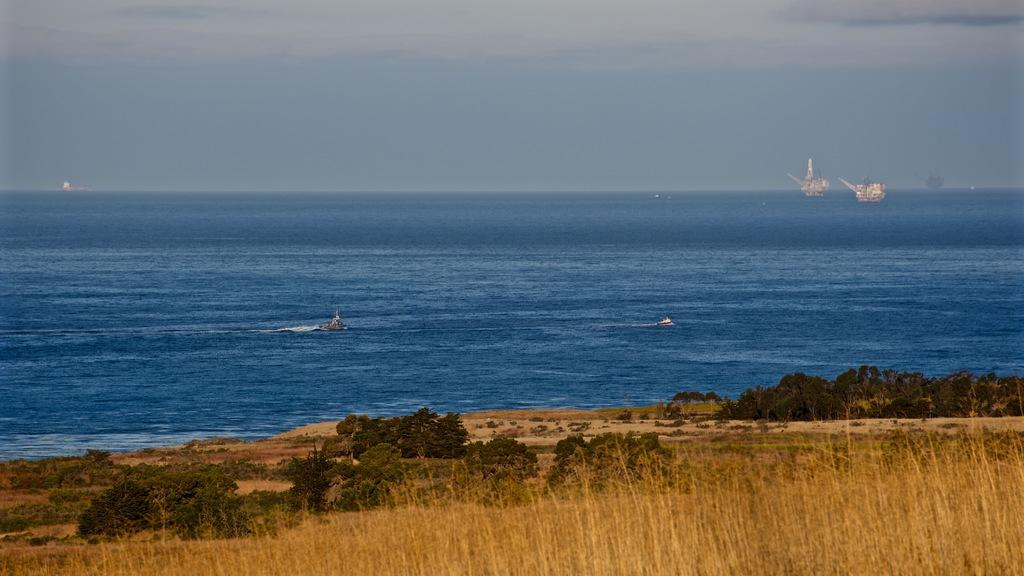What type of vegetation can be seen in the image? There is grass and plants in the image. What is located on the water in the image? There are boats on the water in the image. What is the color of the water in the image? The water is blue in color. What can be seen in the background of the image? The sky is visible in the background of the image. What type of watch is the boat wearing in the image? There are no watches or boats wearing watches in the image. What musical instrument is being played by the plants in the image? There are no musical instruments or plants playing instruments in the image. 